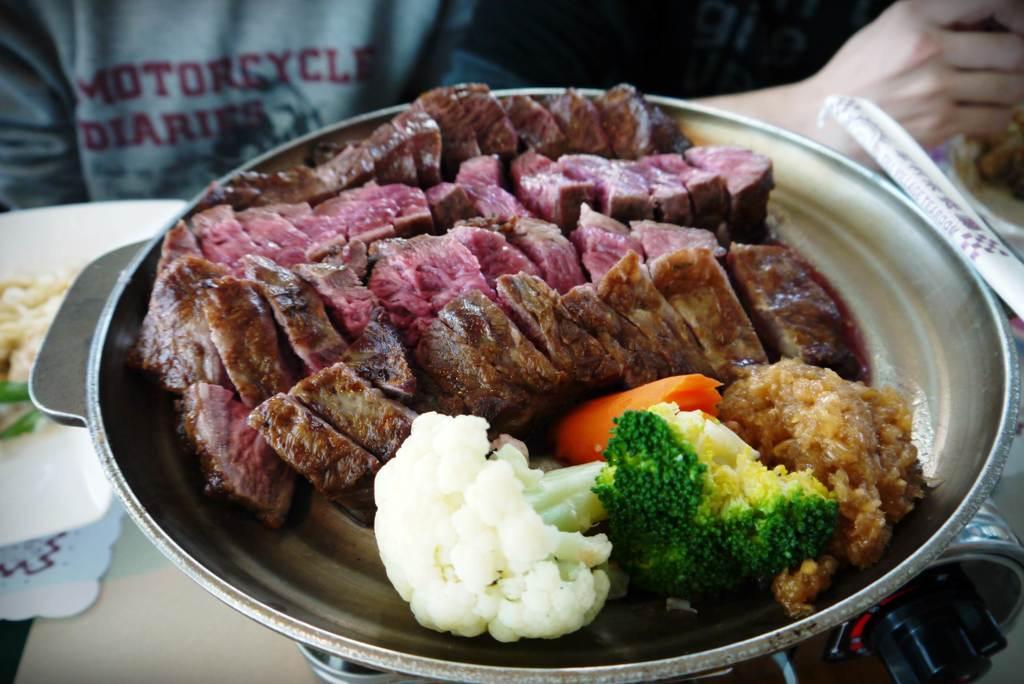Please provide a concise description of this image. In this image, we can see a person bowl contains some food. There is a person hand in the top right of the image. 